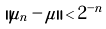<formula> <loc_0><loc_0><loc_500><loc_500>\| \mu _ { n } - \mu \| < 2 ^ { - n }</formula> 